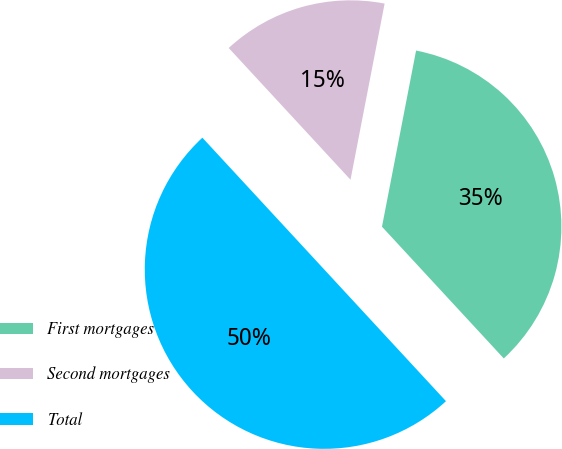Convert chart to OTSL. <chart><loc_0><loc_0><loc_500><loc_500><pie_chart><fcel>First mortgages<fcel>Second mortgages<fcel>Total<nl><fcel>35.08%<fcel>14.92%<fcel>50.0%<nl></chart> 